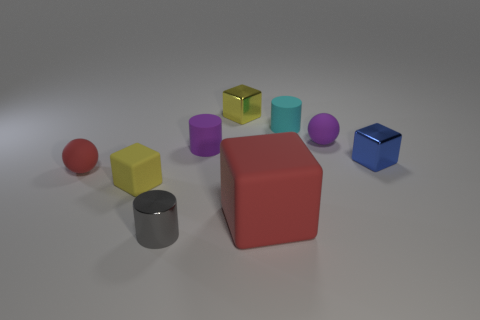Subtract all tiny cyan cylinders. How many cylinders are left? 2 Subtract all spheres. How many objects are left? 7 Subtract all red cubes. How many cubes are left? 3 Subtract 0 cyan balls. How many objects are left? 9 Subtract 1 cylinders. How many cylinders are left? 2 Subtract all brown blocks. Subtract all purple cylinders. How many blocks are left? 4 Subtract all brown cylinders. How many blue cubes are left? 1 Subtract all small red metal cylinders. Subtract all gray things. How many objects are left? 8 Add 5 tiny shiny objects. How many tiny shiny objects are left? 8 Add 5 small cyan rubber objects. How many small cyan rubber objects exist? 6 